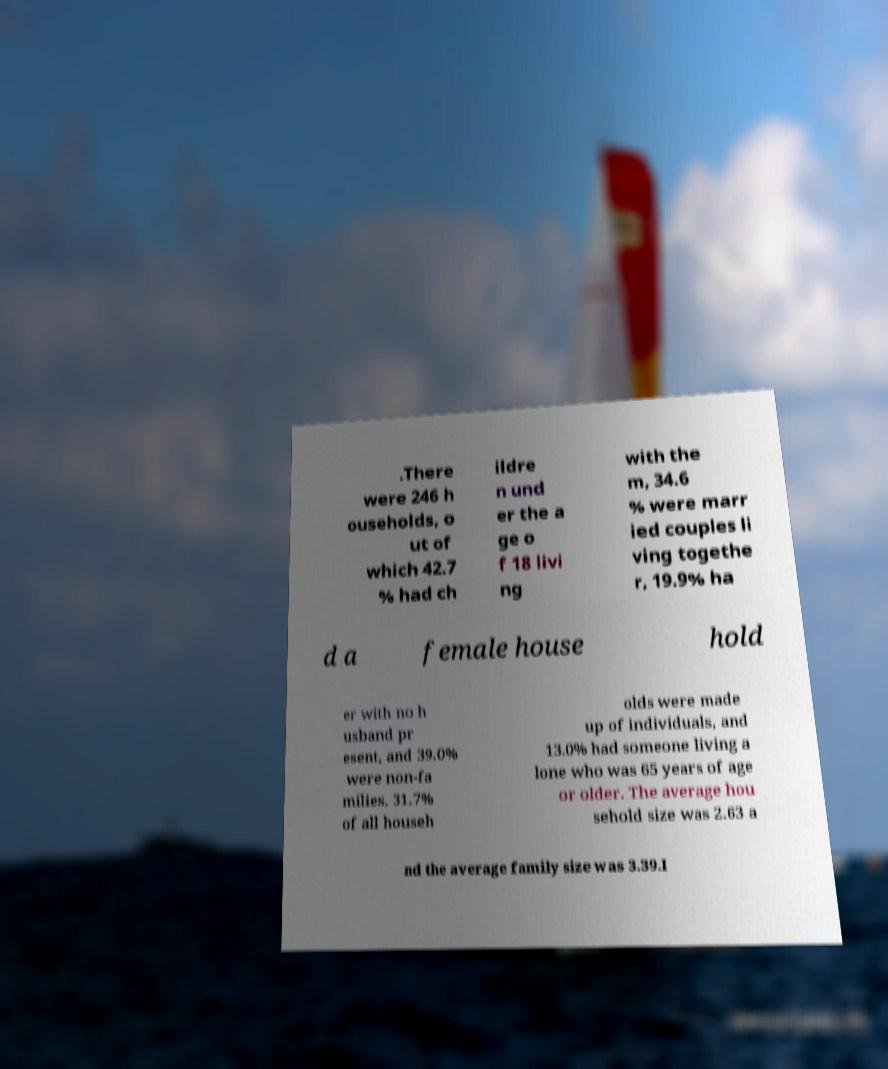Please read and relay the text visible in this image. What does it say? .There were 246 h ouseholds, o ut of which 42.7 % had ch ildre n und er the a ge o f 18 livi ng with the m, 34.6 % were marr ied couples li ving togethe r, 19.9% ha d a female house hold er with no h usband pr esent, and 39.0% were non-fa milies. 31.7% of all househ olds were made up of individuals, and 13.0% had someone living a lone who was 65 years of age or older. The average hou sehold size was 2.63 a nd the average family size was 3.39.I 